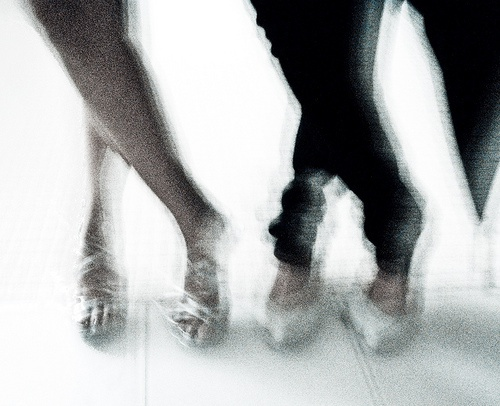Describe the objects in this image and their specific colors. I can see people in lightgray, black, gray, and darkgray tones, people in white, gray, darkgray, lightgray, and black tones, and umbrella in white, black, gray, darkgray, and purple tones in this image. 